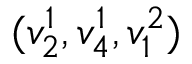<formula> <loc_0><loc_0><loc_500><loc_500>( v _ { 2 } ^ { 1 } , v _ { 4 } ^ { 1 } , v _ { 1 } ^ { 2 } )</formula> 